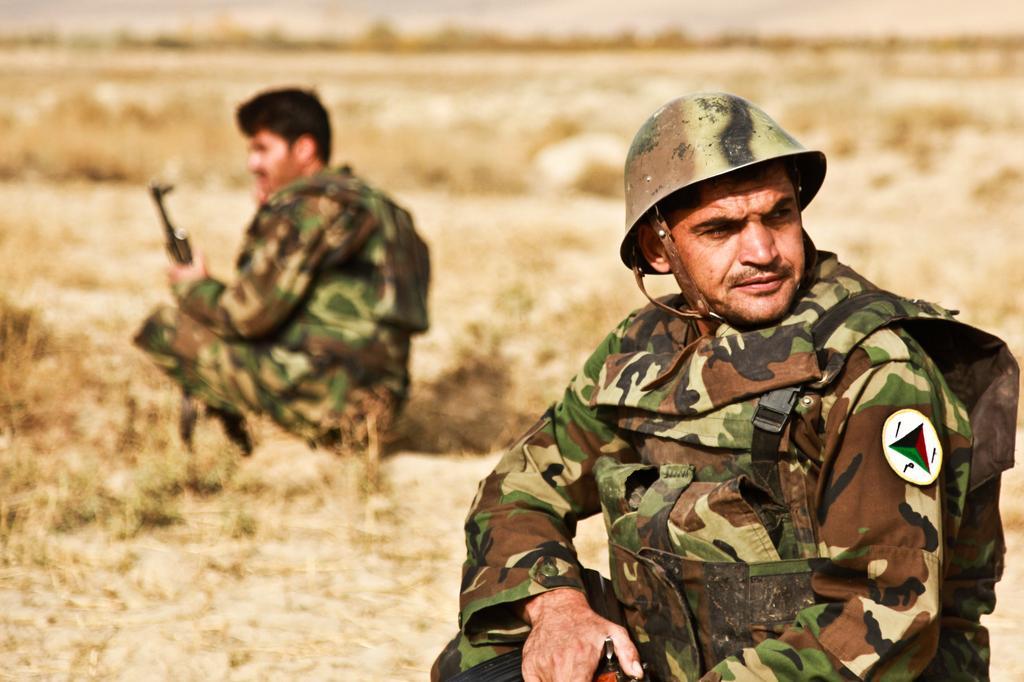Describe this image in one or two sentences. These two people wore military dress and holding guns. Background it is blur. 